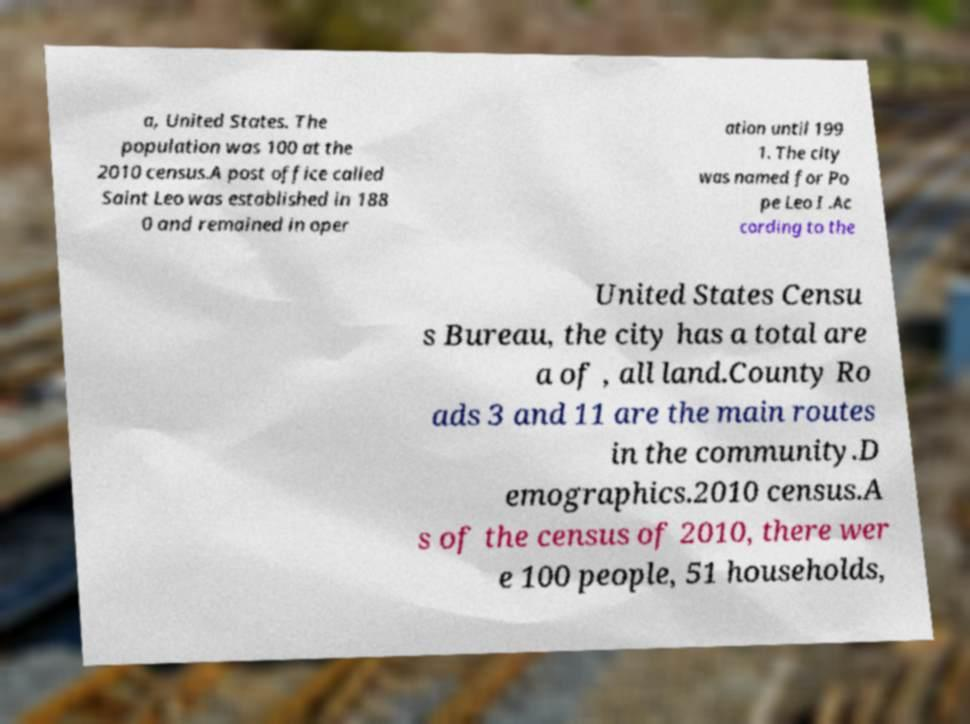There's text embedded in this image that I need extracted. Can you transcribe it verbatim? a, United States. The population was 100 at the 2010 census.A post office called Saint Leo was established in 188 0 and remained in oper ation until 199 1. The city was named for Po pe Leo I .Ac cording to the United States Censu s Bureau, the city has a total are a of , all land.County Ro ads 3 and 11 are the main routes in the community.D emographics.2010 census.A s of the census of 2010, there wer e 100 people, 51 households, 